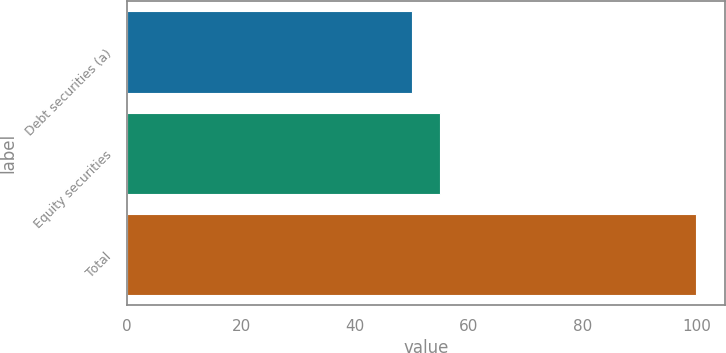Convert chart to OTSL. <chart><loc_0><loc_0><loc_500><loc_500><bar_chart><fcel>Debt securities (a)<fcel>Equity securities<fcel>Total<nl><fcel>50<fcel>55<fcel>100<nl></chart> 